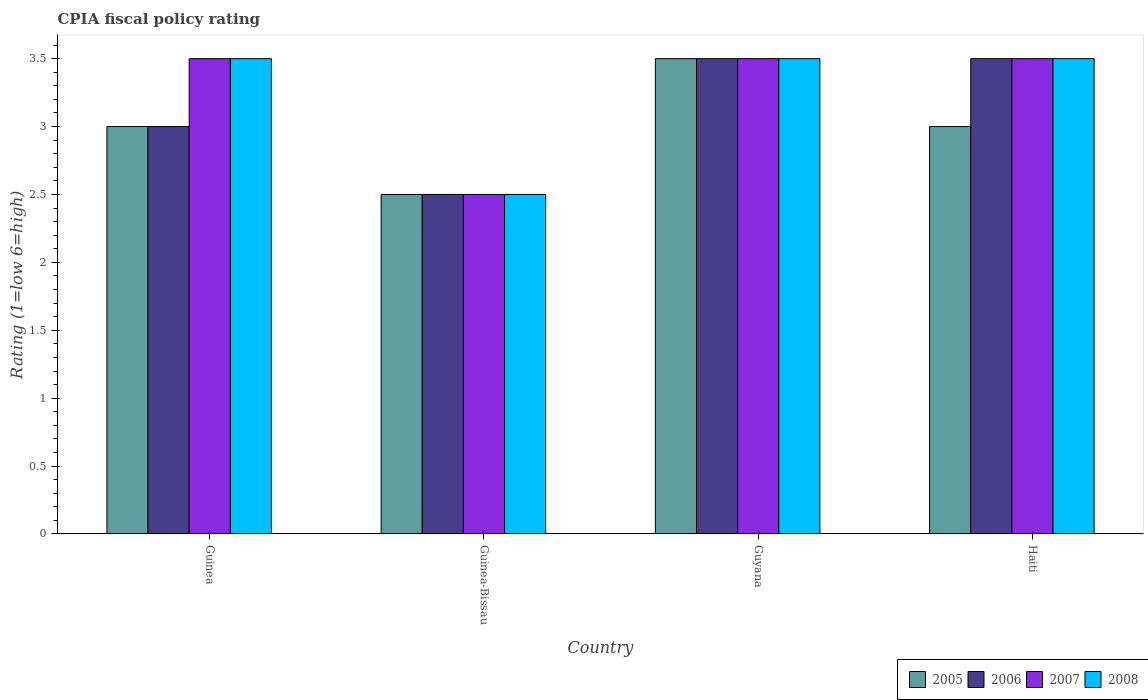Are the number of bars on each tick of the X-axis equal?
Ensure brevity in your answer.  Yes. How many bars are there on the 2nd tick from the right?
Your answer should be compact. 4. What is the label of the 3rd group of bars from the left?
Offer a terse response. Guyana. In how many cases, is the number of bars for a given country not equal to the number of legend labels?
Provide a short and direct response. 0. What is the CPIA rating in 2008 in Guinea-Bissau?
Provide a short and direct response. 2.5. Across all countries, what is the maximum CPIA rating in 2007?
Provide a succinct answer. 3.5. Across all countries, what is the minimum CPIA rating in 2006?
Make the answer very short. 2.5. In which country was the CPIA rating in 2006 maximum?
Your answer should be compact. Guyana. In which country was the CPIA rating in 2008 minimum?
Offer a very short reply. Guinea-Bissau. What is the total CPIA rating in 2006 in the graph?
Provide a short and direct response. 12.5. What is the difference between the CPIA rating in 2008 in Guinea and the CPIA rating in 2005 in Guinea-Bissau?
Your response must be concise. 1. What is the average CPIA rating in 2006 per country?
Keep it short and to the point. 3.12. What is the difference between the CPIA rating of/in 2005 and CPIA rating of/in 2008 in Guyana?
Provide a short and direct response. 0. What is the ratio of the CPIA rating in 2006 in Guinea-Bissau to that in Haiti?
Keep it short and to the point. 0.71. Is the CPIA rating in 2006 in Guinea less than that in Guyana?
Make the answer very short. Yes. Is the difference between the CPIA rating in 2005 in Guinea-Bissau and Guyana greater than the difference between the CPIA rating in 2008 in Guinea-Bissau and Guyana?
Your response must be concise. No. What is the difference between the highest and the second highest CPIA rating in 2006?
Provide a short and direct response. -0.5. Is the sum of the CPIA rating in 2007 in Guinea and Guinea-Bissau greater than the maximum CPIA rating in 2008 across all countries?
Make the answer very short. Yes. What does the 1st bar from the left in Guyana represents?
Offer a very short reply. 2005. Is it the case that in every country, the sum of the CPIA rating in 2005 and CPIA rating in 2007 is greater than the CPIA rating in 2006?
Your response must be concise. Yes. Are all the bars in the graph horizontal?
Your answer should be compact. No. Are the values on the major ticks of Y-axis written in scientific E-notation?
Provide a succinct answer. No. Does the graph contain any zero values?
Ensure brevity in your answer.  No. How many legend labels are there?
Offer a very short reply. 4. How are the legend labels stacked?
Provide a short and direct response. Horizontal. What is the title of the graph?
Your answer should be compact. CPIA fiscal policy rating. What is the label or title of the X-axis?
Your answer should be very brief. Country. What is the label or title of the Y-axis?
Your answer should be very brief. Rating (1=low 6=high). What is the Rating (1=low 6=high) of 2007 in Guinea?
Provide a short and direct response. 3.5. What is the Rating (1=low 6=high) in 2006 in Guinea-Bissau?
Provide a short and direct response. 2.5. What is the Rating (1=low 6=high) in 2008 in Guinea-Bissau?
Provide a short and direct response. 2.5. What is the Rating (1=low 6=high) of 2008 in Guyana?
Provide a succinct answer. 3.5. What is the Rating (1=low 6=high) of 2005 in Haiti?
Your response must be concise. 3. What is the Rating (1=low 6=high) of 2006 in Haiti?
Provide a succinct answer. 3.5. What is the Rating (1=low 6=high) in 2008 in Haiti?
Your response must be concise. 3.5. Across all countries, what is the maximum Rating (1=low 6=high) in 2005?
Your answer should be compact. 3.5. Across all countries, what is the maximum Rating (1=low 6=high) of 2006?
Provide a succinct answer. 3.5. Across all countries, what is the maximum Rating (1=low 6=high) in 2007?
Provide a succinct answer. 3.5. Across all countries, what is the minimum Rating (1=low 6=high) in 2005?
Give a very brief answer. 2.5. Across all countries, what is the minimum Rating (1=low 6=high) of 2008?
Your answer should be compact. 2.5. What is the total Rating (1=low 6=high) of 2006 in the graph?
Ensure brevity in your answer.  12.5. What is the difference between the Rating (1=low 6=high) of 2005 in Guinea and that in Guinea-Bissau?
Make the answer very short. 0.5. What is the difference between the Rating (1=low 6=high) of 2006 in Guinea and that in Guinea-Bissau?
Give a very brief answer. 0.5. What is the difference between the Rating (1=low 6=high) of 2006 in Guinea and that in Guyana?
Your answer should be compact. -0.5. What is the difference between the Rating (1=low 6=high) in 2007 in Guinea and that in Guyana?
Ensure brevity in your answer.  0. What is the difference between the Rating (1=low 6=high) in 2008 in Guinea and that in Guyana?
Offer a very short reply. 0. What is the difference between the Rating (1=low 6=high) in 2007 in Guinea and that in Haiti?
Your response must be concise. 0. What is the difference between the Rating (1=low 6=high) of 2005 in Guinea-Bissau and that in Guyana?
Offer a very short reply. -1. What is the difference between the Rating (1=low 6=high) in 2008 in Guinea-Bissau and that in Guyana?
Your response must be concise. -1. What is the difference between the Rating (1=low 6=high) of 2005 in Guinea-Bissau and that in Haiti?
Your answer should be very brief. -0.5. What is the difference between the Rating (1=low 6=high) in 2007 in Guinea-Bissau and that in Haiti?
Your answer should be compact. -1. What is the difference between the Rating (1=low 6=high) in 2008 in Guinea-Bissau and that in Haiti?
Offer a terse response. -1. What is the difference between the Rating (1=low 6=high) of 2006 in Guyana and that in Haiti?
Your answer should be very brief. 0. What is the difference between the Rating (1=low 6=high) of 2005 in Guinea and the Rating (1=low 6=high) of 2007 in Guinea-Bissau?
Offer a terse response. 0.5. What is the difference between the Rating (1=low 6=high) of 2006 in Guinea and the Rating (1=low 6=high) of 2007 in Guinea-Bissau?
Make the answer very short. 0.5. What is the difference between the Rating (1=low 6=high) of 2006 in Guinea and the Rating (1=low 6=high) of 2008 in Guinea-Bissau?
Make the answer very short. 0.5. What is the difference between the Rating (1=low 6=high) of 2005 in Guinea and the Rating (1=low 6=high) of 2006 in Guyana?
Keep it short and to the point. -0.5. What is the difference between the Rating (1=low 6=high) of 2005 in Guinea and the Rating (1=low 6=high) of 2007 in Guyana?
Your answer should be compact. -0.5. What is the difference between the Rating (1=low 6=high) in 2006 in Guinea and the Rating (1=low 6=high) in 2007 in Guyana?
Your response must be concise. -0.5. What is the difference between the Rating (1=low 6=high) in 2007 in Guinea and the Rating (1=low 6=high) in 2008 in Guyana?
Offer a very short reply. 0. What is the difference between the Rating (1=low 6=high) in 2005 in Guinea and the Rating (1=low 6=high) in 2006 in Haiti?
Provide a succinct answer. -0.5. What is the difference between the Rating (1=low 6=high) in 2005 in Guinea and the Rating (1=low 6=high) in 2007 in Haiti?
Provide a short and direct response. -0.5. What is the difference between the Rating (1=low 6=high) in 2005 in Guinea and the Rating (1=low 6=high) in 2008 in Haiti?
Give a very brief answer. -0.5. What is the difference between the Rating (1=low 6=high) of 2007 in Guinea and the Rating (1=low 6=high) of 2008 in Haiti?
Keep it short and to the point. 0. What is the difference between the Rating (1=low 6=high) in 2005 in Guinea-Bissau and the Rating (1=low 6=high) in 2006 in Guyana?
Ensure brevity in your answer.  -1. What is the difference between the Rating (1=low 6=high) in 2005 in Guinea-Bissau and the Rating (1=low 6=high) in 2008 in Guyana?
Your response must be concise. -1. What is the difference between the Rating (1=low 6=high) of 2006 in Guinea-Bissau and the Rating (1=low 6=high) of 2008 in Guyana?
Provide a succinct answer. -1. What is the difference between the Rating (1=low 6=high) in 2005 in Guinea-Bissau and the Rating (1=low 6=high) in 2007 in Haiti?
Provide a short and direct response. -1. What is the difference between the Rating (1=low 6=high) in 2005 in Guinea-Bissau and the Rating (1=low 6=high) in 2008 in Haiti?
Offer a terse response. -1. What is the difference between the Rating (1=low 6=high) of 2006 in Guinea-Bissau and the Rating (1=low 6=high) of 2007 in Haiti?
Keep it short and to the point. -1. What is the difference between the Rating (1=low 6=high) in 2006 in Guinea-Bissau and the Rating (1=low 6=high) in 2008 in Haiti?
Offer a terse response. -1. What is the difference between the Rating (1=low 6=high) of 2007 in Guinea-Bissau and the Rating (1=low 6=high) of 2008 in Haiti?
Your answer should be compact. -1. What is the difference between the Rating (1=low 6=high) of 2005 in Guyana and the Rating (1=low 6=high) of 2006 in Haiti?
Your response must be concise. 0. What is the difference between the Rating (1=low 6=high) in 2005 in Guyana and the Rating (1=low 6=high) in 2008 in Haiti?
Ensure brevity in your answer.  0. What is the difference between the Rating (1=low 6=high) in 2007 in Guyana and the Rating (1=low 6=high) in 2008 in Haiti?
Give a very brief answer. 0. What is the average Rating (1=low 6=high) of 2006 per country?
Give a very brief answer. 3.12. What is the average Rating (1=low 6=high) in 2008 per country?
Your answer should be compact. 3.25. What is the difference between the Rating (1=low 6=high) in 2007 and Rating (1=low 6=high) in 2008 in Guinea?
Your response must be concise. 0. What is the difference between the Rating (1=low 6=high) in 2006 and Rating (1=low 6=high) in 2007 in Guinea-Bissau?
Provide a succinct answer. 0. What is the difference between the Rating (1=low 6=high) of 2006 and Rating (1=low 6=high) of 2008 in Guinea-Bissau?
Keep it short and to the point. 0. What is the difference between the Rating (1=low 6=high) of 2005 and Rating (1=low 6=high) of 2007 in Guyana?
Your answer should be very brief. 0. What is the difference between the Rating (1=low 6=high) of 2005 and Rating (1=low 6=high) of 2008 in Guyana?
Provide a succinct answer. 0. What is the difference between the Rating (1=low 6=high) of 2006 and Rating (1=low 6=high) of 2007 in Guyana?
Give a very brief answer. 0. What is the difference between the Rating (1=low 6=high) of 2006 and Rating (1=low 6=high) of 2008 in Guyana?
Give a very brief answer. 0. What is the difference between the Rating (1=low 6=high) of 2007 and Rating (1=low 6=high) of 2008 in Guyana?
Your response must be concise. 0. What is the difference between the Rating (1=low 6=high) of 2005 and Rating (1=low 6=high) of 2007 in Haiti?
Ensure brevity in your answer.  -0.5. What is the difference between the Rating (1=low 6=high) of 2005 and Rating (1=low 6=high) of 2008 in Haiti?
Ensure brevity in your answer.  -0.5. What is the difference between the Rating (1=low 6=high) in 2006 and Rating (1=low 6=high) in 2008 in Haiti?
Make the answer very short. 0. What is the ratio of the Rating (1=low 6=high) of 2005 in Guinea to that in Guinea-Bissau?
Provide a succinct answer. 1.2. What is the ratio of the Rating (1=low 6=high) of 2007 in Guinea to that in Guinea-Bissau?
Give a very brief answer. 1.4. What is the ratio of the Rating (1=low 6=high) of 2008 in Guinea to that in Guinea-Bissau?
Your answer should be compact. 1.4. What is the ratio of the Rating (1=low 6=high) of 2005 in Guinea to that in Guyana?
Provide a succinct answer. 0.86. What is the ratio of the Rating (1=low 6=high) in 2007 in Guinea to that in Guyana?
Keep it short and to the point. 1. What is the ratio of the Rating (1=low 6=high) in 2005 in Guinea to that in Haiti?
Offer a very short reply. 1. What is the ratio of the Rating (1=low 6=high) of 2007 in Guinea to that in Haiti?
Offer a terse response. 1. What is the ratio of the Rating (1=low 6=high) in 2006 in Guinea-Bissau to that in Guyana?
Your answer should be compact. 0.71. What is the ratio of the Rating (1=low 6=high) in 2008 in Guinea-Bissau to that in Guyana?
Offer a very short reply. 0.71. What is the ratio of the Rating (1=low 6=high) in 2005 in Guinea-Bissau to that in Haiti?
Your response must be concise. 0.83. What is the ratio of the Rating (1=low 6=high) in 2006 in Guinea-Bissau to that in Haiti?
Offer a very short reply. 0.71. What is the ratio of the Rating (1=low 6=high) of 2005 in Guyana to that in Haiti?
Provide a succinct answer. 1.17. What is the ratio of the Rating (1=low 6=high) in 2006 in Guyana to that in Haiti?
Offer a terse response. 1. What is the difference between the highest and the second highest Rating (1=low 6=high) in 2006?
Offer a terse response. 0. What is the difference between the highest and the second highest Rating (1=low 6=high) in 2007?
Give a very brief answer. 0. What is the difference between the highest and the second highest Rating (1=low 6=high) of 2008?
Keep it short and to the point. 0. What is the difference between the highest and the lowest Rating (1=low 6=high) in 2005?
Your response must be concise. 1. What is the difference between the highest and the lowest Rating (1=low 6=high) in 2008?
Give a very brief answer. 1. 